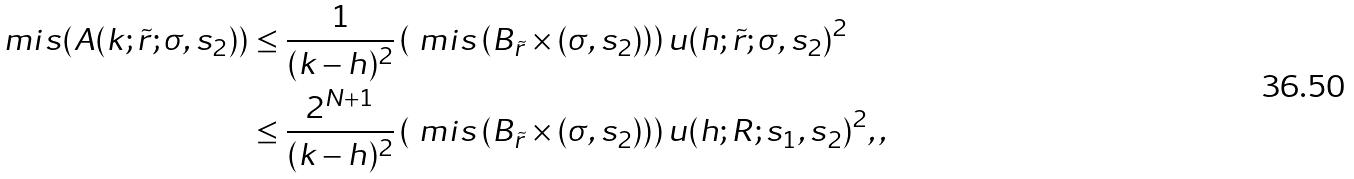<formula> <loc_0><loc_0><loc_500><loc_500>\ m i s ( A ( k ; \tilde { r } ; \sigma , s _ { 2 } ) ) & \leq \frac { 1 } { ( k - h ) ^ { 2 } } \left ( \ m i s \left ( B _ { \tilde { r } } \times ( \sigma , s _ { 2 } ) \right ) \right ) u ( h ; \tilde { r } ; \sigma , s _ { 2 } ) ^ { 2 } \\ & \leq \frac { 2 ^ { N + 1 } } { ( k - h ) ^ { 2 } } \left ( \ m i s \left ( B _ { \tilde { r } } \times ( \sigma , s _ { 2 } ) \right ) \right ) u ( h ; R ; s _ { 1 } , s _ { 2 } ) ^ { 2 } , ,</formula> 